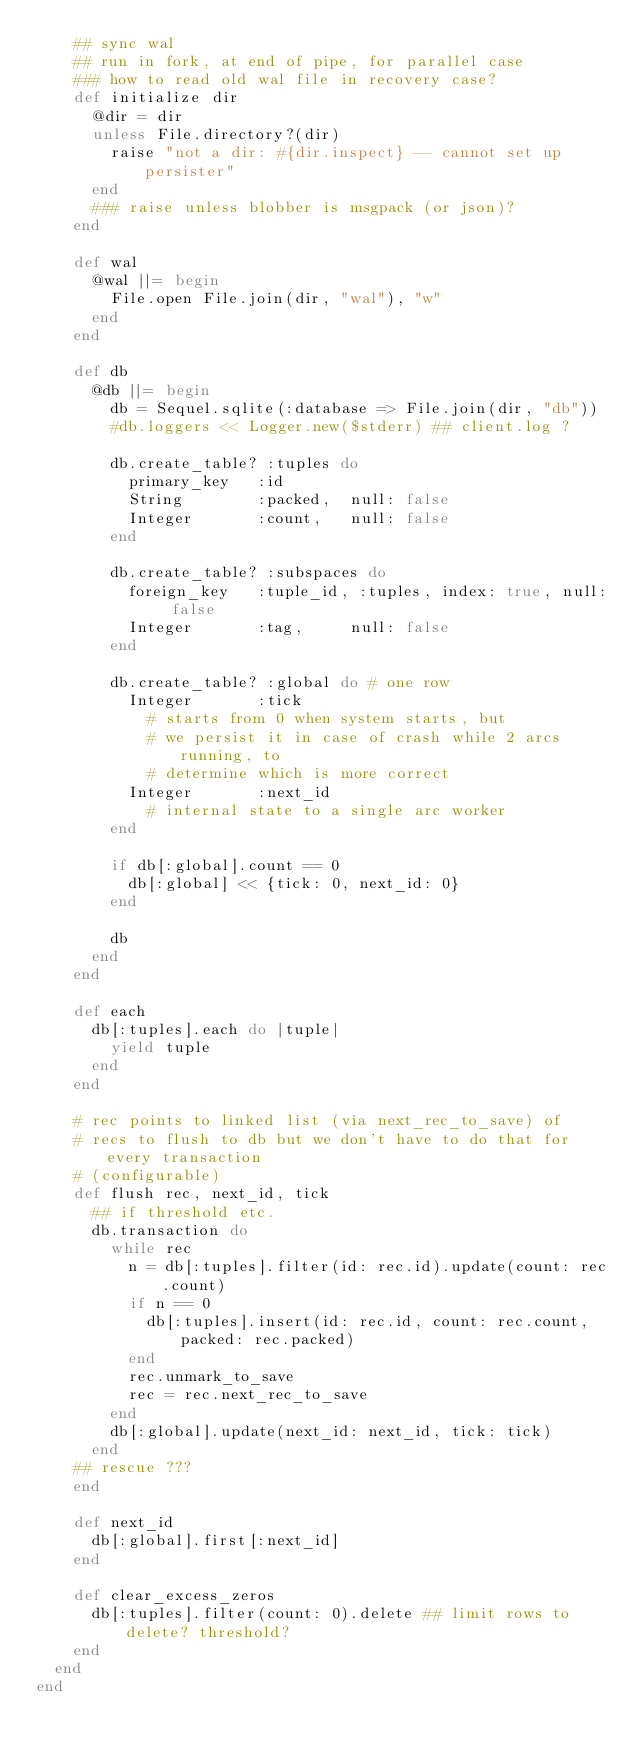<code> <loc_0><loc_0><loc_500><loc_500><_Ruby_>    ## sync wal
    ## run in fork, at end of pipe, for parallel case
    ### how to read old wal file in recovery case?
    def initialize dir
      @dir = dir
      unless File.directory?(dir)
        raise "not a dir: #{dir.inspect} -- cannot set up persister"
      end
      ### raise unless blobber is msgpack (or json)?
    end
    
    def wal
      @wal ||= begin
        File.open File.join(dir, "wal"), "w"
      end
    end
    
    def db
      @db ||= begin
        db = Sequel.sqlite(:database => File.join(dir, "db"))
        #db.loggers << Logger.new($stderr) ## client.log ?

        db.create_table? :tuples do
          primary_key   :id
          String        :packed,  null: false
          Integer       :count,   null: false
        end

        db.create_table? :subspaces do
          foreign_key   :tuple_id, :tuples, index: true, null: false
          Integer       :tag,     null: false
        end

        db.create_table? :global do # one row
          Integer       :tick
            # starts from 0 when system starts, but
            # we persist it in case of crash while 2 arcs running, to
            # determine which is more correct
          Integer       :next_id
            # internal state to a single arc worker
        end
        
        if db[:global].count == 0
          db[:global] << {tick: 0, next_id: 0}
        end

        db
      end
    end
    
    def each
      db[:tuples].each do |tuple|
        yield tuple
      end
    end
    
    # rec points to linked list (via next_rec_to_save) of
    # recs to flush to db but we don't have to do that for every transaction
    # (configurable)
    def flush rec, next_id, tick
      ## if threshold etc.
      db.transaction do
        while rec
          n = db[:tuples].filter(id: rec.id).update(count: rec.count)
          if n == 0
            db[:tuples].insert(id: rec.id, count: rec.count, packed: rec.packed)
          end
          rec.unmark_to_save
          rec = rec.next_rec_to_save
        end
        db[:global].update(next_id: next_id, tick: tick)
      end
    ## rescue ???
    end
    
    def next_id
      db[:global].first[:next_id]
    end
    
    def clear_excess_zeros
      db[:tuples].filter(count: 0).delete ## limit rows to delete? threshold?
    end
  end
end
</code> 